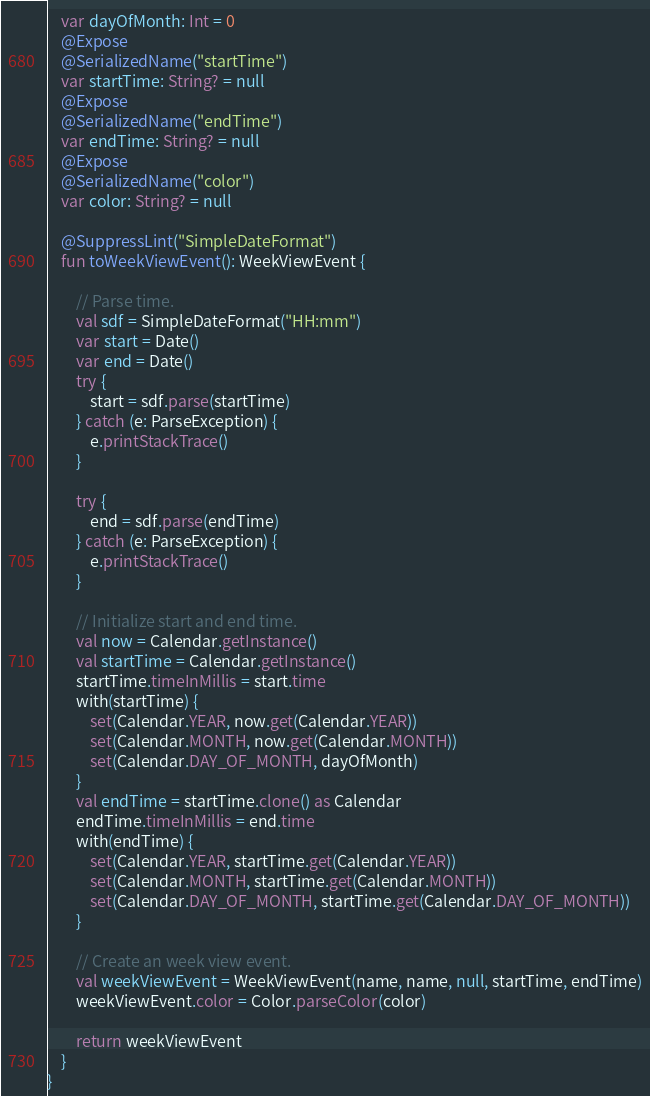<code> <loc_0><loc_0><loc_500><loc_500><_Kotlin_>    var dayOfMonth: Int = 0
    @Expose
    @SerializedName("startTime")
    var startTime: String? = null
    @Expose
    @SerializedName("endTime")
    var endTime: String? = null
    @Expose
    @SerializedName("color")
    var color: String? = null

    @SuppressLint("SimpleDateFormat")
    fun toWeekViewEvent(): WeekViewEvent {

        // Parse time.
        val sdf = SimpleDateFormat("HH:mm")
        var start = Date()
        var end = Date()
        try {
            start = sdf.parse(startTime)
        } catch (e: ParseException) {
            e.printStackTrace()
        }

        try {
            end = sdf.parse(endTime)
        } catch (e: ParseException) {
            e.printStackTrace()
        }

        // Initialize start and end time.
        val now = Calendar.getInstance()
        val startTime = Calendar.getInstance()
        startTime.timeInMillis = start.time
        with(startTime) {
            set(Calendar.YEAR, now.get(Calendar.YEAR))
            set(Calendar.MONTH, now.get(Calendar.MONTH))
            set(Calendar.DAY_OF_MONTH, dayOfMonth)
        }
        val endTime = startTime.clone() as Calendar
        endTime.timeInMillis = end.time
        with(endTime) {
            set(Calendar.YEAR, startTime.get(Calendar.YEAR))
            set(Calendar.MONTH, startTime.get(Calendar.MONTH))
            set(Calendar.DAY_OF_MONTH, startTime.get(Calendar.DAY_OF_MONTH))
        }

        // Create an week view event.
        val weekViewEvent = WeekViewEvent(name, name, null, startTime, endTime)
        weekViewEvent.color = Color.parseColor(color)

        return weekViewEvent
    }
}
</code> 